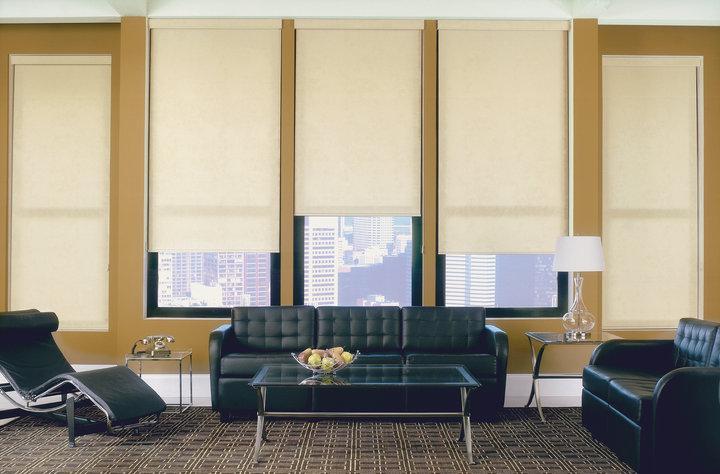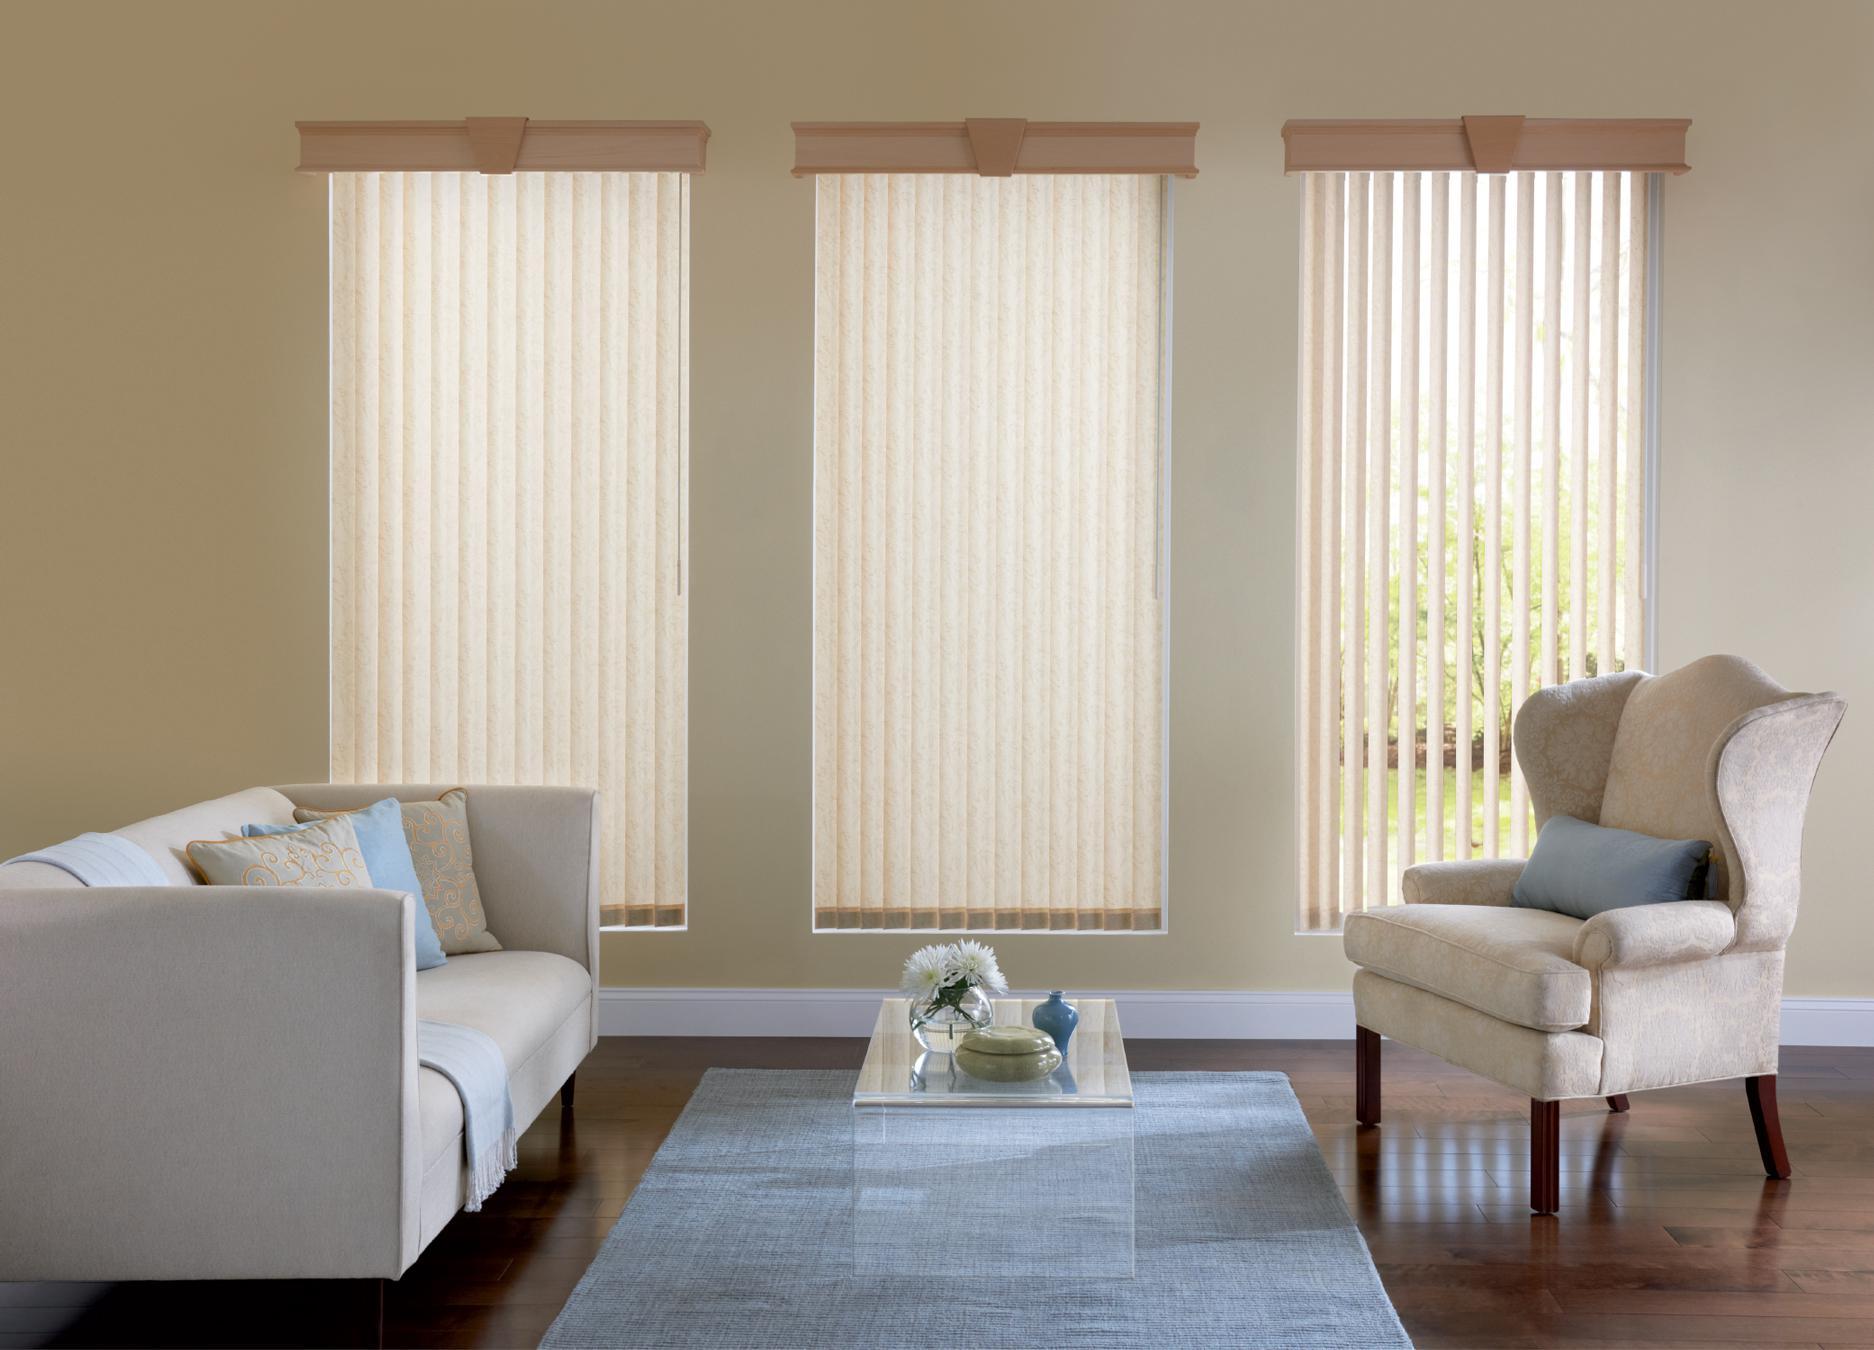The first image is the image on the left, the second image is the image on the right. Considering the images on both sides, is "The left image shows one shade with a straight bottom hanging in front of, but not fully covering, a white paned window." valid? Answer yes or no. No. 